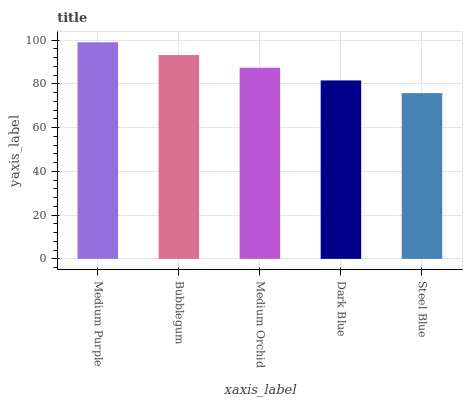Is Steel Blue the minimum?
Answer yes or no. Yes. Is Medium Purple the maximum?
Answer yes or no. Yes. Is Bubblegum the minimum?
Answer yes or no. No. Is Bubblegum the maximum?
Answer yes or no. No. Is Medium Purple greater than Bubblegum?
Answer yes or no. Yes. Is Bubblegum less than Medium Purple?
Answer yes or no. Yes. Is Bubblegum greater than Medium Purple?
Answer yes or no. No. Is Medium Purple less than Bubblegum?
Answer yes or no. No. Is Medium Orchid the high median?
Answer yes or no. Yes. Is Medium Orchid the low median?
Answer yes or no. Yes. Is Bubblegum the high median?
Answer yes or no. No. Is Steel Blue the low median?
Answer yes or no. No. 